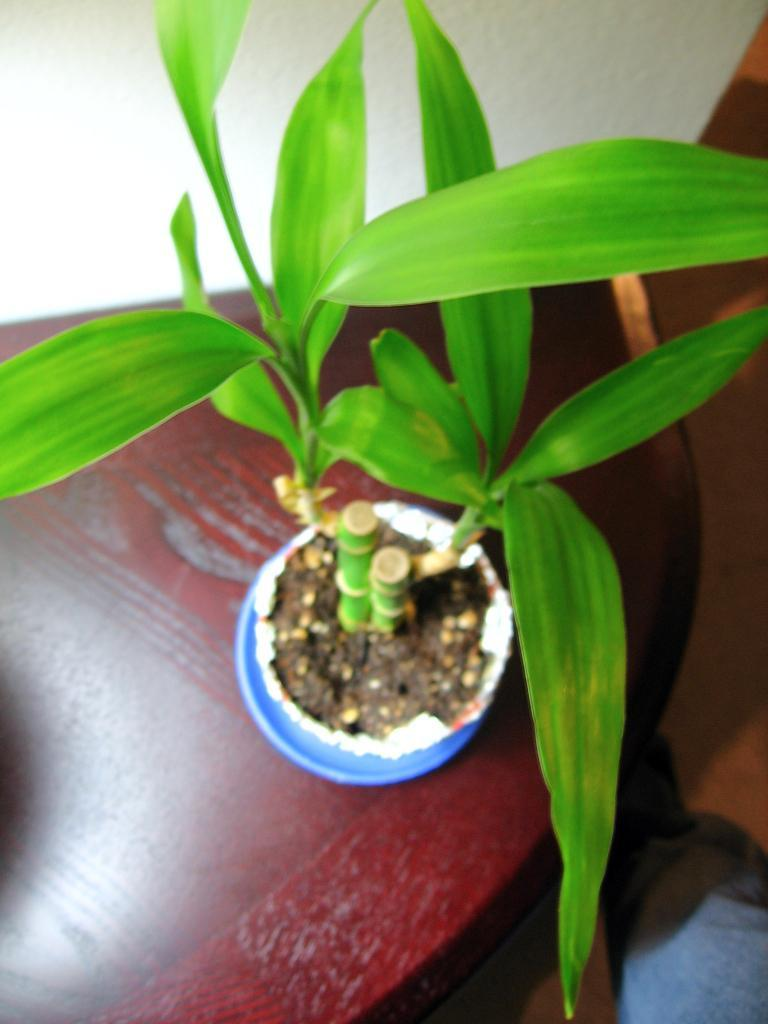What is placed on the table in the image? There is a plant on a table in the image. What color is the wall visible in the image? There is a white-colored wall on the side in the image. Are there any ants crawling on the plant in the image? There is no indication of ants or any other insects in the image; it only shows a plant on a table and a white-colored wall. 